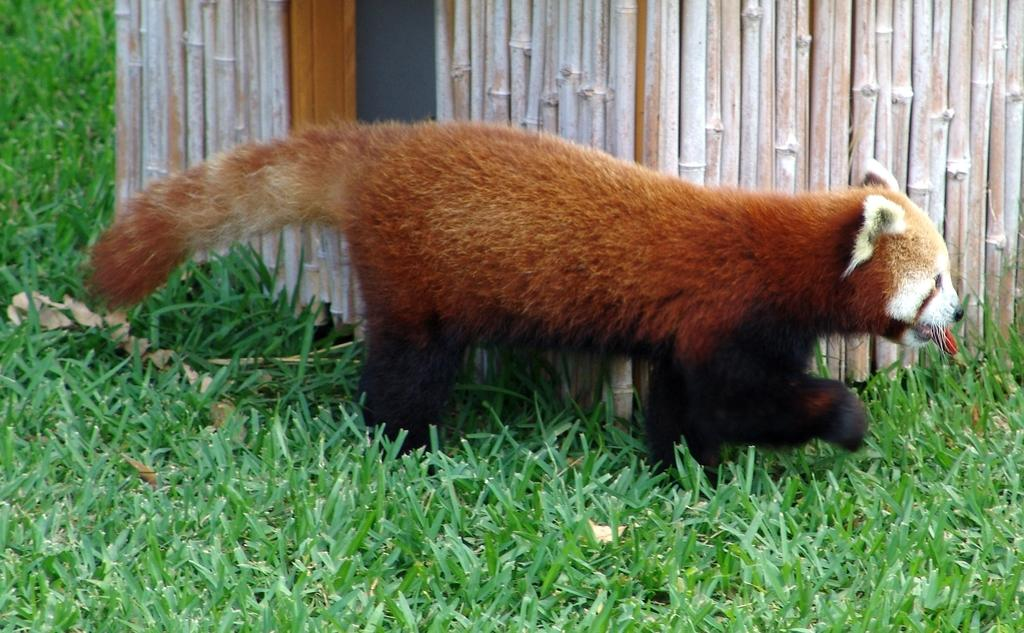What type of animal is in the image? There is a red panda in the image. What is the red panda doing in the image? The red panda is walking on the grass. What can be seen on the roof in the image? There are bamboo shoots on the roof. What type of knife is the stranger holding in the image? There is no stranger or knife present in the image. 